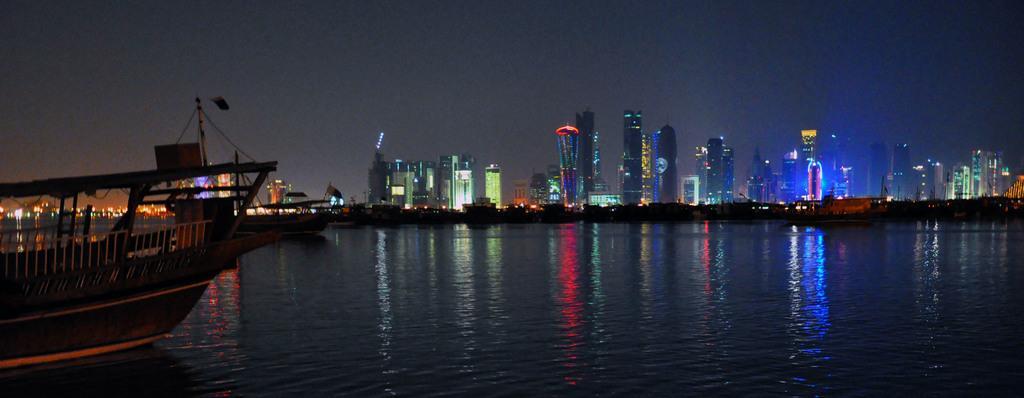Please provide a concise description of this image. In this picture we can see a few boats in the water. There are the reflections of colorful lights in the water. We can see a few buildings and some lights in these buildings in the background. 